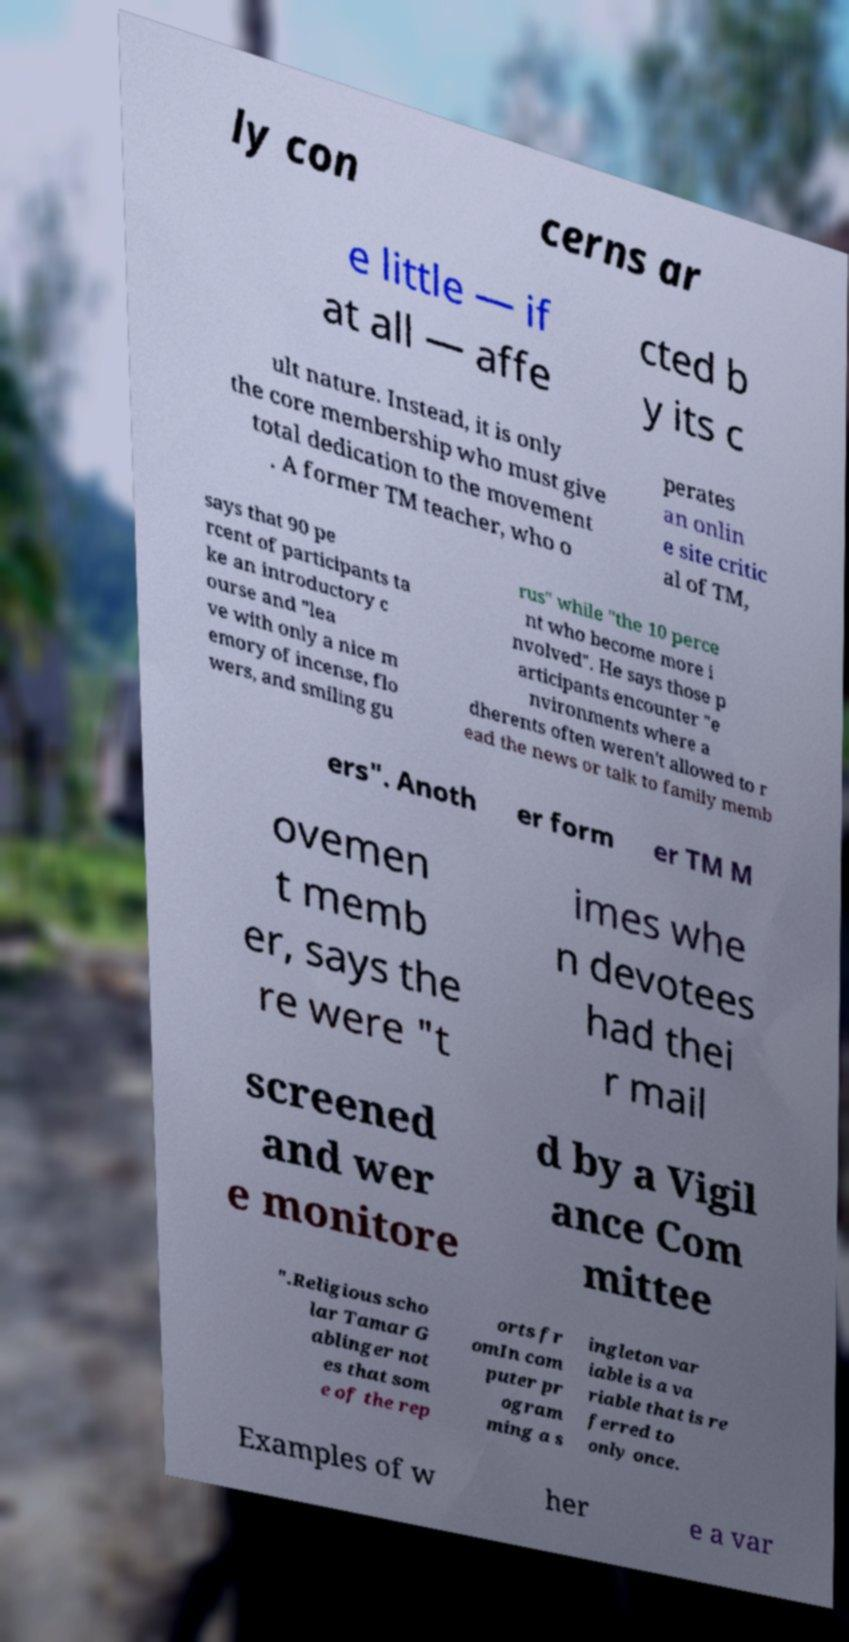There's text embedded in this image that I need extracted. Can you transcribe it verbatim? ly con cerns ar e little — if at all — affe cted b y its c ult nature. Instead, it is only the core membership who must give total dedication to the movement . A former TM teacher, who o perates an onlin e site critic al of TM, says that 90 pe rcent of participants ta ke an introductory c ourse and "lea ve with only a nice m emory of incense, flo wers, and smiling gu rus" while "the 10 perce nt who become more i nvolved". He says those p articipants encounter "e nvironments where a dherents often weren't allowed to r ead the news or talk to family memb ers". Anoth er form er TM M ovemen t memb er, says the re were "t imes whe n devotees had thei r mail screened and wer e monitore d by a Vigil ance Com mittee ".Religious scho lar Tamar G ablinger not es that som e of the rep orts fr omIn com puter pr ogram ming a s ingleton var iable is a va riable that is re ferred to only once. Examples of w her e a var 